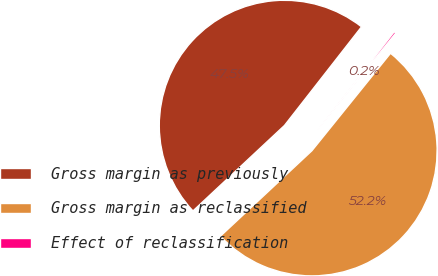Convert chart. <chart><loc_0><loc_0><loc_500><loc_500><pie_chart><fcel>Gross margin as previously<fcel>Gross margin as reclassified<fcel>Effect of reclassification<nl><fcel>47.51%<fcel>52.24%<fcel>0.25%<nl></chart> 